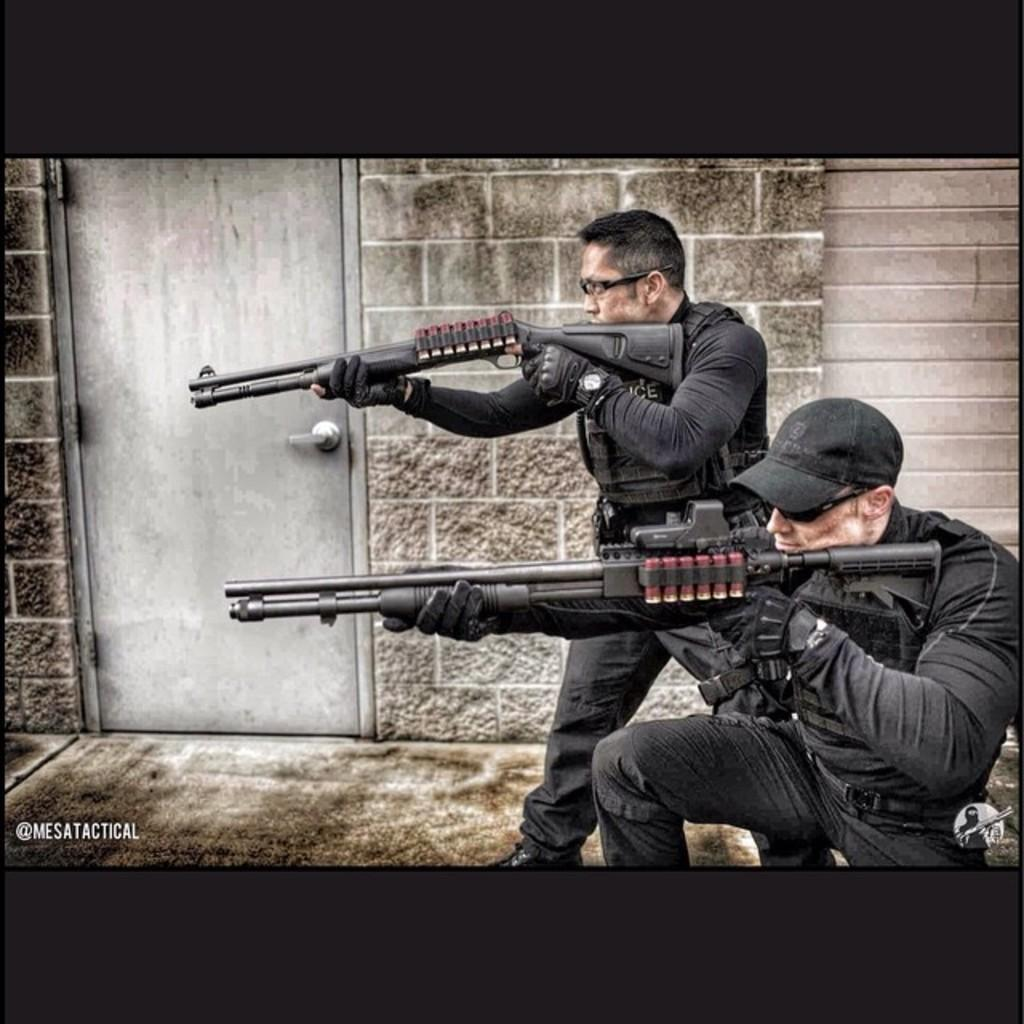How many people are in the image? There are two persons in the image. What are the persons holding in their hands? The persons are holding guns in the image. What type of structure can be seen in the background? There is a wall and a door in the image. Is there any text present in the image? Yes, there is text on the image. What color are the borders of the image? The borders of the image are black in color. What time is displayed on the clock in the image? There is no clock present in the image. What caption is written below the image? The image does not have a caption; it only contains text within the image itself. 